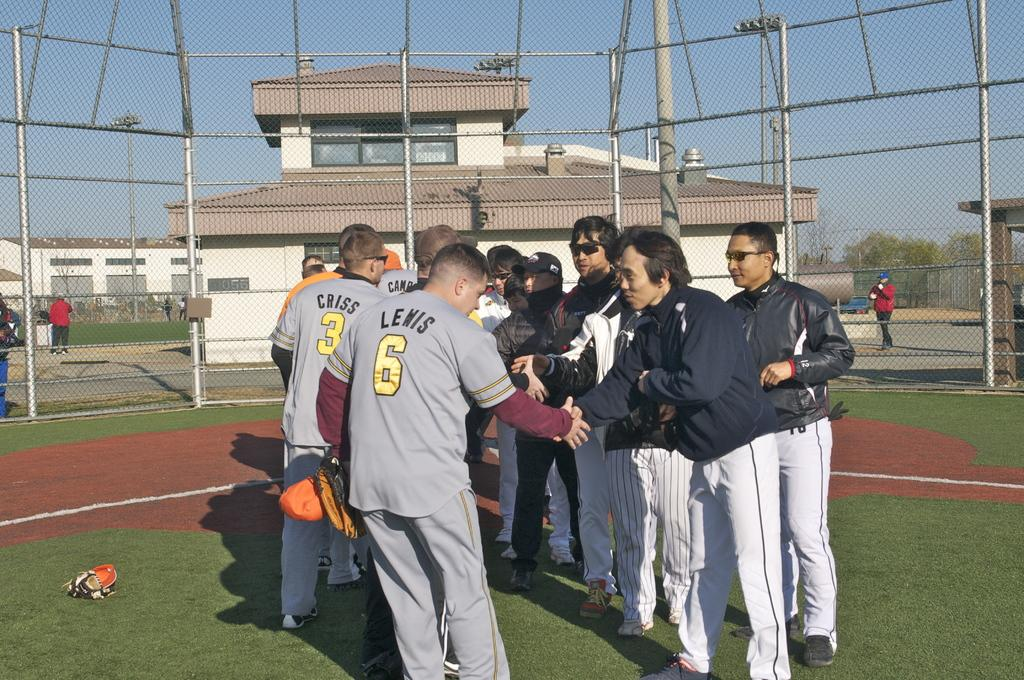Provide a one-sentence caption for the provided image. Sports players with the numbers 6 and 3 shake hands with a group of other people. 